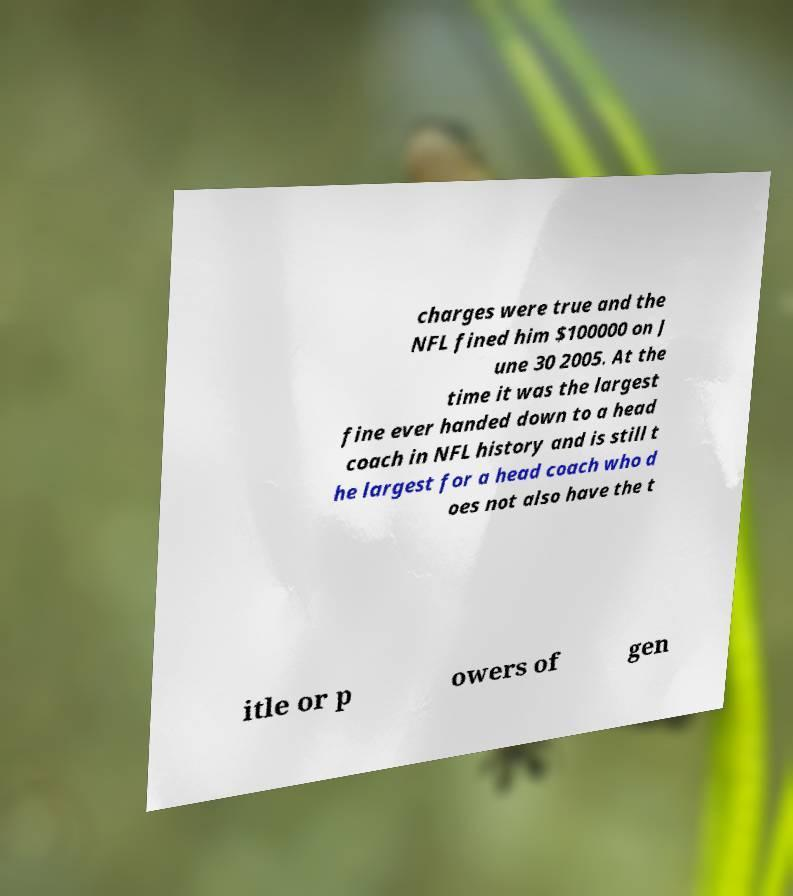Can you accurately transcribe the text from the provided image for me? charges were true and the NFL fined him $100000 on J une 30 2005. At the time it was the largest fine ever handed down to a head coach in NFL history and is still t he largest for a head coach who d oes not also have the t itle or p owers of gen 